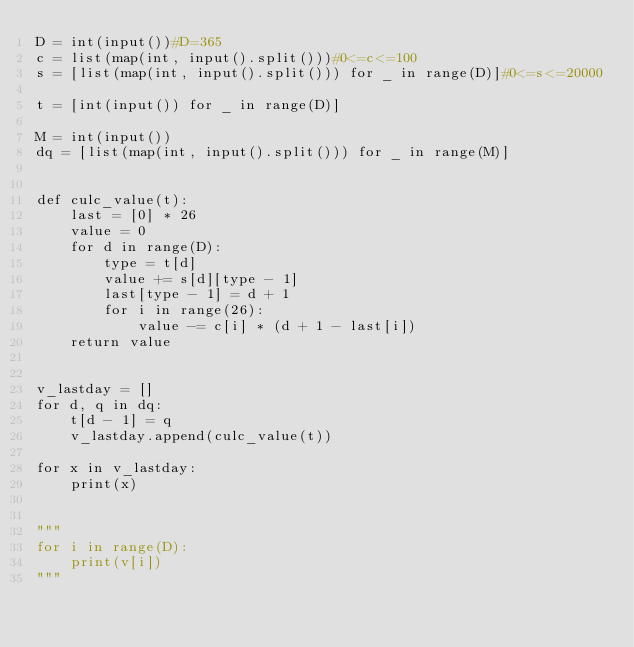Convert code to text. <code><loc_0><loc_0><loc_500><loc_500><_Python_>D = int(input())#D=365
c = list(map(int, input().split()))#0<=c<=100
s = [list(map(int, input().split())) for _ in range(D)]#0<=s<=20000

t = [int(input()) for _ in range(D)]

M = int(input())
dq = [list(map(int, input().split())) for _ in range(M)]


def culc_value(t):
    last = [0] * 26
    value = 0
    for d in range(D):
        type = t[d]
        value += s[d][type - 1]
        last[type - 1] = d + 1
        for i in range(26):
            value -= c[i] * (d + 1 - last[i])
    return value


v_lastday = []
for d, q in dq:
    t[d - 1] = q
    v_lastday.append(culc_value(t))

for x in v_lastday:
    print(x)


"""
for i in range(D):
    print(v[i])
"""</code> 